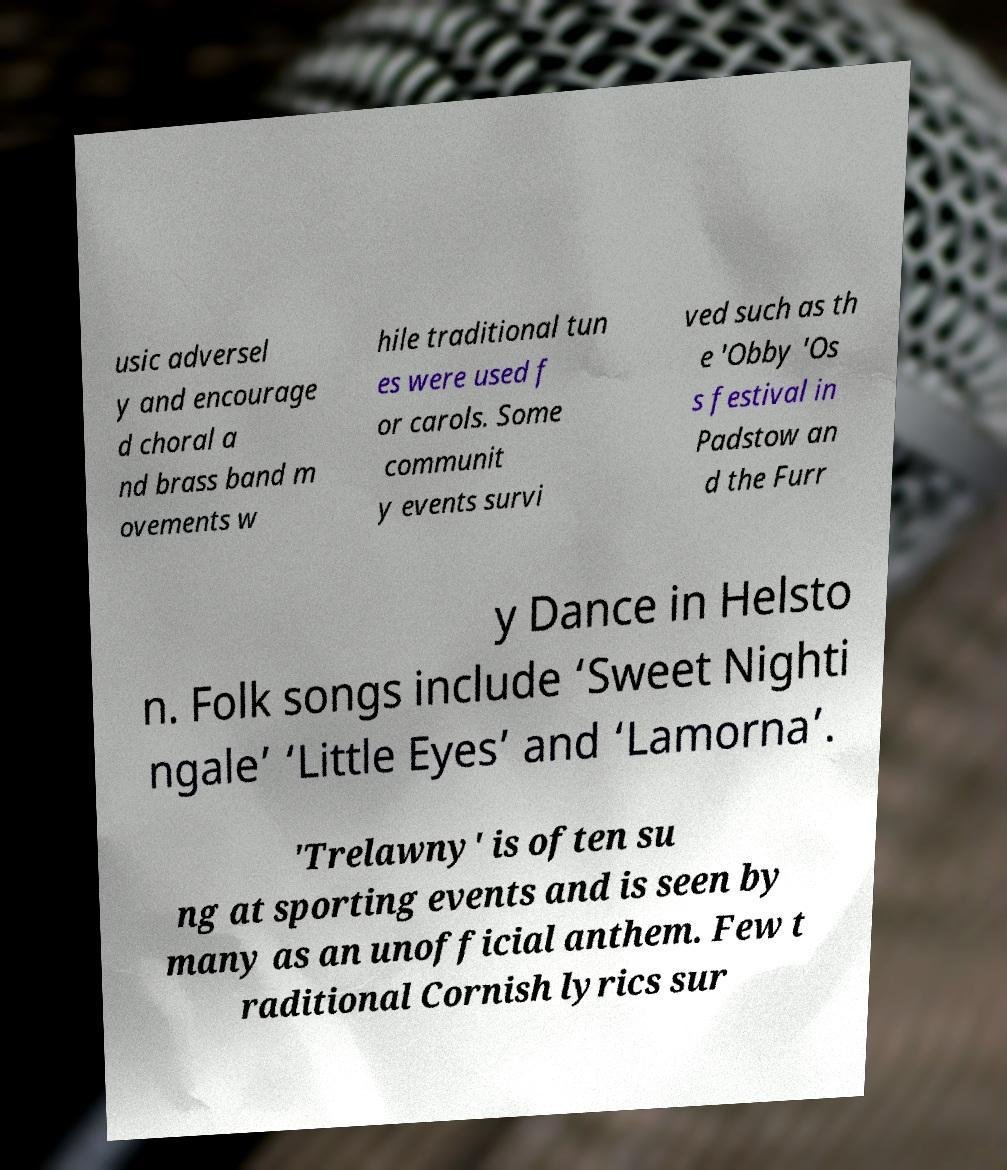What messages or text are displayed in this image? I need them in a readable, typed format. usic adversel y and encourage d choral a nd brass band m ovements w hile traditional tun es were used f or carols. Some communit y events survi ved such as th e 'Obby 'Os s festival in Padstow an d the Furr y Dance in Helsto n. Folk songs include ‘Sweet Nighti ngale’ ‘Little Eyes’ and ‘Lamorna’. 'Trelawny' is often su ng at sporting events and is seen by many as an unofficial anthem. Few t raditional Cornish lyrics sur 